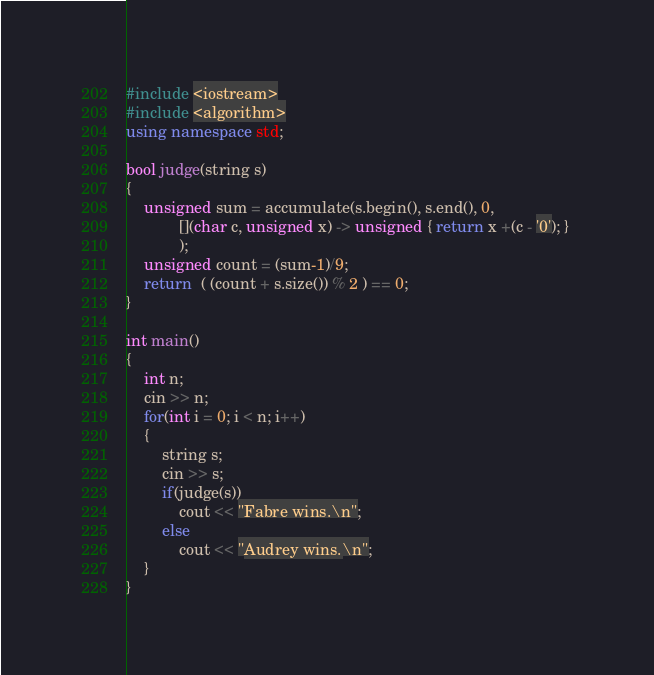<code> <loc_0><loc_0><loc_500><loc_500><_C++_>#include <iostream>
#include <algorithm>
using namespace std;

bool judge(string s)
{
    unsigned sum = accumulate(s.begin(), s.end(), 0,
            [](char c, unsigned x) -> unsigned { return x +(c - '0'); } 
            );
    unsigned count = (sum-1)/9;
    return  ( (count + s.size()) % 2 ) == 0;
}

int main()
{
    int n;
    cin >> n;
    for(int i = 0; i < n; i++)
    {
        string s;
        cin >> s;
        if(judge(s))
            cout << "Fabre wins.\n";
        else
            cout << "Audrey wins.\n";
    }
}</code> 